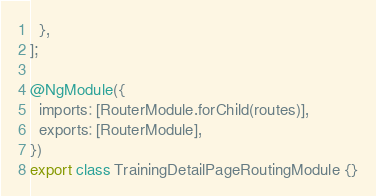Convert code to text. <code><loc_0><loc_0><loc_500><loc_500><_TypeScript_>  },
];

@NgModule({
  imports: [RouterModule.forChild(routes)],
  exports: [RouterModule],
})
export class TrainingDetailPageRoutingModule {}
</code> 